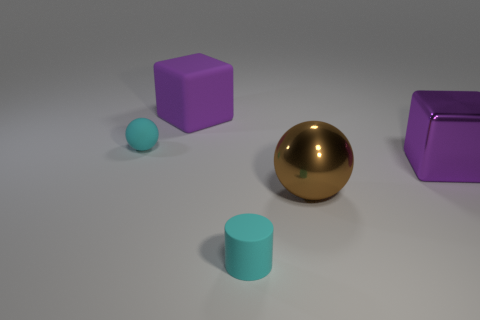Subtract all brown spheres. How many spheres are left? 1 Subtract 1 balls. How many balls are left? 1 Add 4 big brown balls. How many big brown balls are left? 5 Add 4 small things. How many small things exist? 6 Add 5 large matte objects. How many objects exist? 10 Subtract 0 cyan blocks. How many objects are left? 5 Subtract all spheres. How many objects are left? 3 Subtract all red blocks. Subtract all green cylinders. How many blocks are left? 2 Subtract all green cylinders. How many brown spheres are left? 1 Subtract all big metal objects. Subtract all purple blocks. How many objects are left? 1 